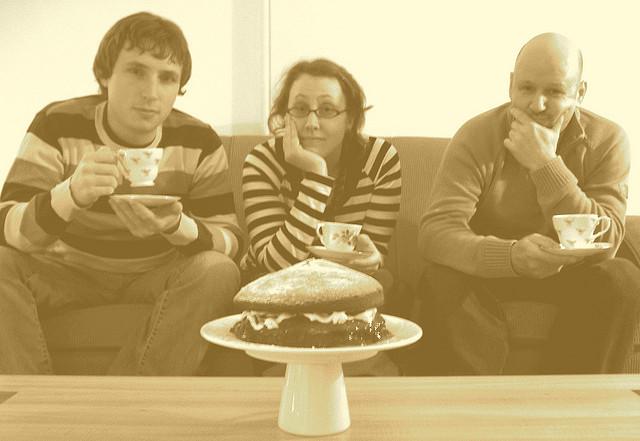How many people are there?
Write a very short answer. 3. How many women?
Quick response, please. 1. What food is on the table?
Answer briefly. Cake. 